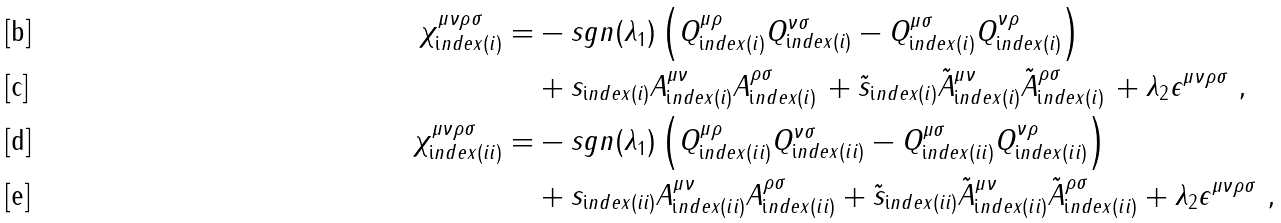Convert formula to latex. <formula><loc_0><loc_0><loc_500><loc_500>\chi _ { \text  index{(i)} } ^ { \mu \nu \rho \sigma } = & - s g n ( \lambda _ { 1 } ) \left ( Q _ { \text  index{(i)} } ^ { \mu \rho } Q _ { \text  index{(i)} } ^ { \nu \sigma } - Q _ { \text  index{(i)} } ^ { \mu \sigma } Q _ { \text  index{(i)} } ^ { \nu \rho } \right ) \\ & + s _ { \text  index{(i)} } A _ { \text  index{(i)} } ^ { \mu \nu } A _ { \text  index{(i)} } ^ { \rho \sigma } \, + \tilde { s } _ { \text  index{(i)} } \tilde { A } _ { \text  index{(i)} } ^ { \mu \nu } \tilde { A } _ { \text  index{(i)} } ^ { \rho \sigma } \, + \lambda _ { 2 } \epsilon ^ { \mu \nu \rho \sigma } \ , \\ \chi _ { \text  index{(ii)} } ^ { \mu \nu \rho \sigma } = & - s g n ( \lambda _ { 1 } ) \left ( Q _ { \text  index{(ii)} } ^ { \mu \rho } Q _ { \text  index{(ii)} } ^ { \nu \sigma } - Q _ { \text  index{(ii)} } ^ { \mu \sigma } Q _ { \text  index{(ii)} } ^ { \nu \rho } \right ) \\ & + s _ { \text  index{(ii)} } A _ { \text  index{(ii)} } ^ { \mu \nu } A _ { \text  index{(ii)} } ^ { \rho \sigma } + \tilde { s } _ { \text  index{(ii)} } \tilde { A } _ { \text  index{(ii)} } ^ { \mu \nu } \tilde { A } _ { \text  index{(ii)} } ^ { \rho \sigma } + \lambda _ { 2 } \epsilon ^ { \mu \nu \rho \sigma } \ ,</formula> 